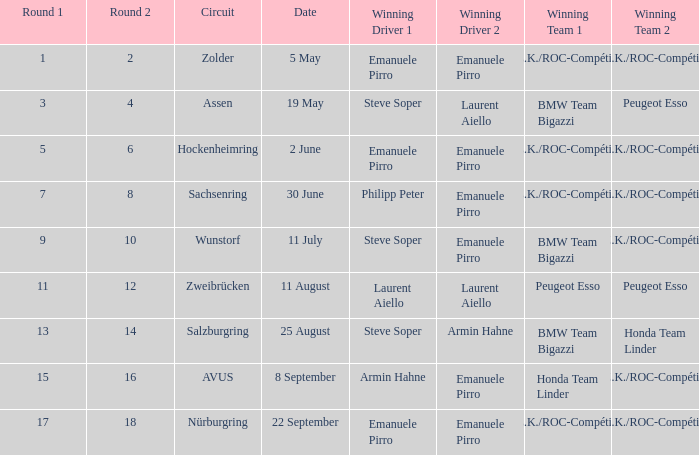What is the round on 30 june where a.z.k./roc-compétition emerges as the winning squad? 7 8. 